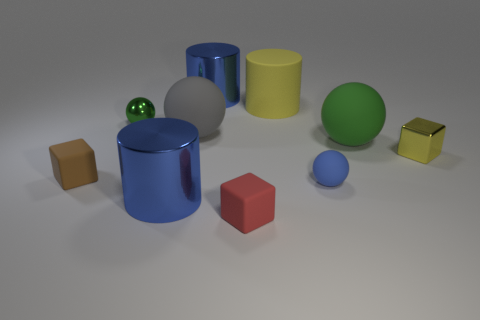Subtract all brown balls. Subtract all red cylinders. How many balls are left? 4 Subtract all balls. How many objects are left? 6 Subtract all blue metallic balls. Subtract all green spheres. How many objects are left? 8 Add 9 large gray things. How many large gray things are left? 10 Add 2 blue metal cylinders. How many blue metal cylinders exist? 4 Subtract 1 yellow cylinders. How many objects are left? 9 